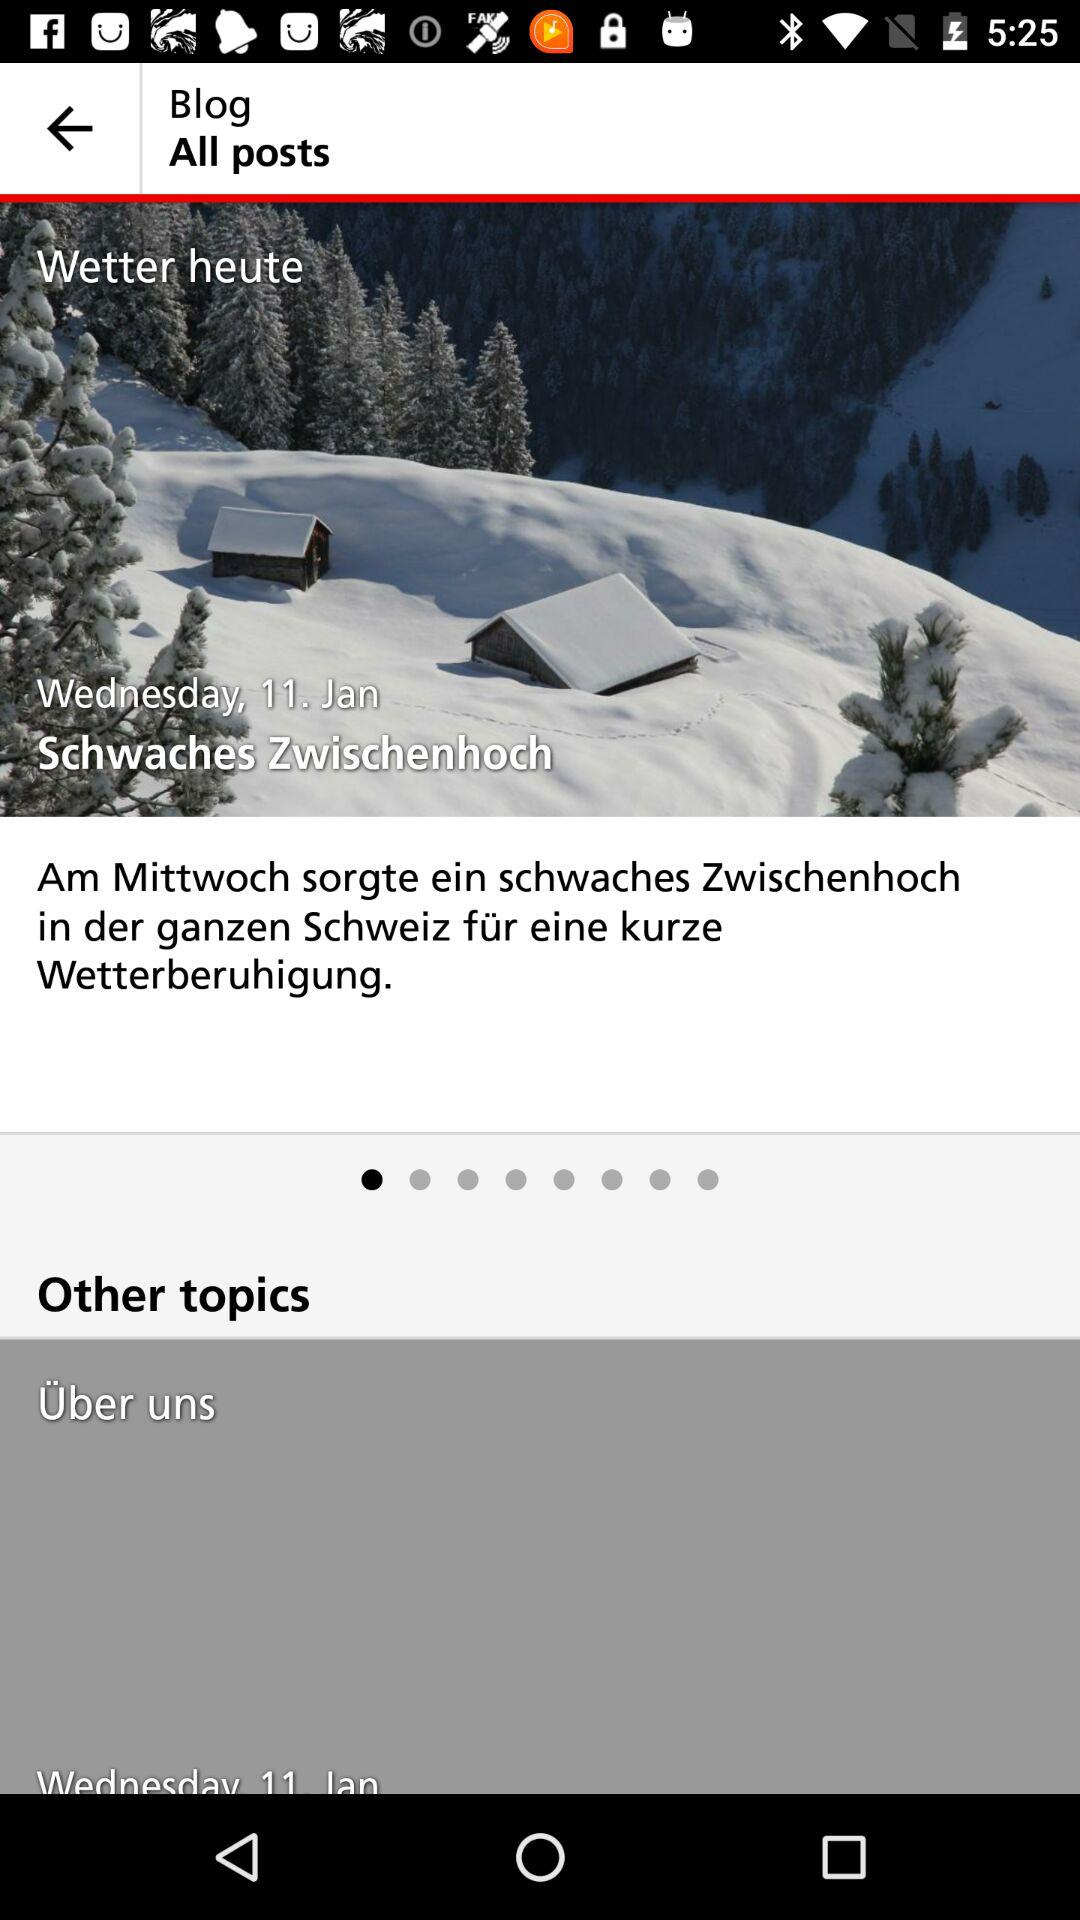What is the date on January 11? The day on January 11 is Wednesday. 